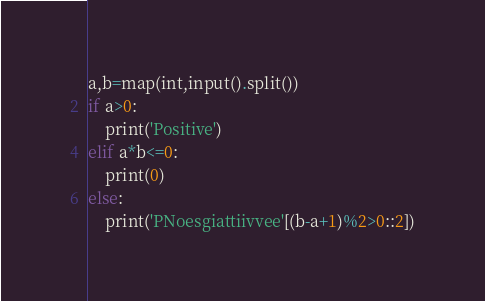<code> <loc_0><loc_0><loc_500><loc_500><_Python_>a,b=map(int,input().split())
if a>0:
	print('Positive')
elif a*b<=0:
	print(0)
else:
	print('PNoesgiattiivvee'[(b-a+1)%2>0::2])</code> 